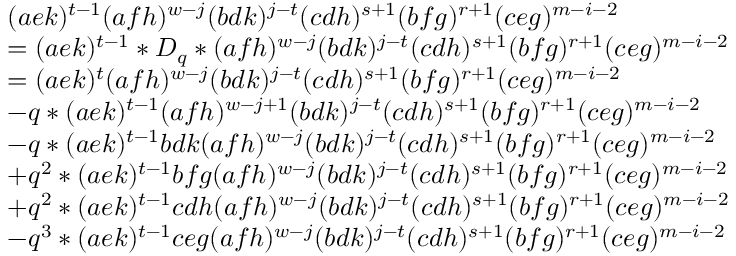Convert formula to latex. <formula><loc_0><loc_0><loc_500><loc_500>\begin{array} { r l } & { ( a e k ) ^ { t - 1 } ( a f h ) ^ { w - j } ( b d k ) ^ { j - t } ( c d h ) ^ { s + 1 } ( b f g ) ^ { r + 1 } ( c e g ) ^ { m - i - 2 } } \\ & { = ( a e k ) ^ { t - 1 } * D _ { q } * ( a f h ) ^ { w - j } ( b d k ) ^ { j - t } ( c d h ) ^ { s + 1 } ( b f g ) ^ { r + 1 } ( c e g ) ^ { m - i - 2 } } \\ & { = ( a e k ) ^ { t } ( a f h ) ^ { w - j } ( b d k ) ^ { j - t } ( c d h ) ^ { s + 1 } ( b f g ) ^ { r + 1 } ( c e g ) ^ { m - i - 2 } } \\ & { - q * ( a e k ) ^ { t - 1 } ( a f h ) ^ { w - j + 1 } ( b d k ) ^ { j - t } ( c d h ) ^ { s + 1 } ( b f g ) ^ { r + 1 } ( c e g ) ^ { m - i - 2 } } \\ & { - q * ( a e k ) ^ { t - 1 } b d k ( a f h ) ^ { w - j } ( b d k ) ^ { j - t } ( c d h ) ^ { s + 1 } ( b f g ) ^ { r + 1 } ( c e g ) ^ { m - i - 2 } } \\ & { + q ^ { 2 } * ( a e k ) ^ { t - 1 } b f g ( a f h ) ^ { w - j } ( b d k ) ^ { j - t } ( c d h ) ^ { s + 1 } ( b f g ) ^ { r + 1 } ( c e g ) ^ { m - i - 2 } } \\ & { + q ^ { 2 } * ( a e k ) ^ { t - 1 } c d h ( a f h ) ^ { w - j } ( b d k ) ^ { j - t } ( c d h ) ^ { s + 1 } ( b f g ) ^ { r + 1 } ( c e g ) ^ { m - i - 2 } } \\ & { - q ^ { 3 } * ( a e k ) ^ { t - 1 } c e g ( a f h ) ^ { w - j } ( b d k ) ^ { j - t } ( c d h ) ^ { s + 1 } ( b f g ) ^ { r + 1 } ( c e g ) ^ { m - i - 2 } } \end{array}</formula> 